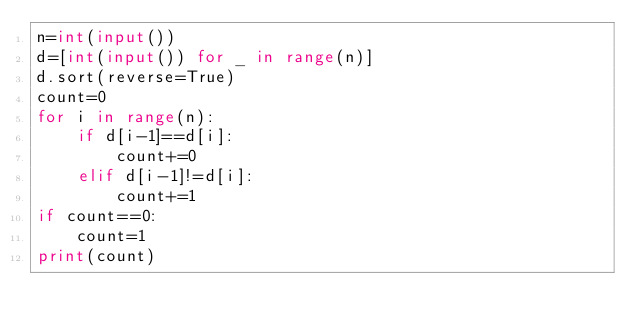Convert code to text. <code><loc_0><loc_0><loc_500><loc_500><_Python_>n=int(input())
d=[int(input()) for _ in range(n)]
d.sort(reverse=True)
count=0
for i in range(n):
    if d[i-1]==d[i]:
        count+=0
    elif d[i-1]!=d[i]:
        count+=1
if count==0:
    count=1
print(count)</code> 